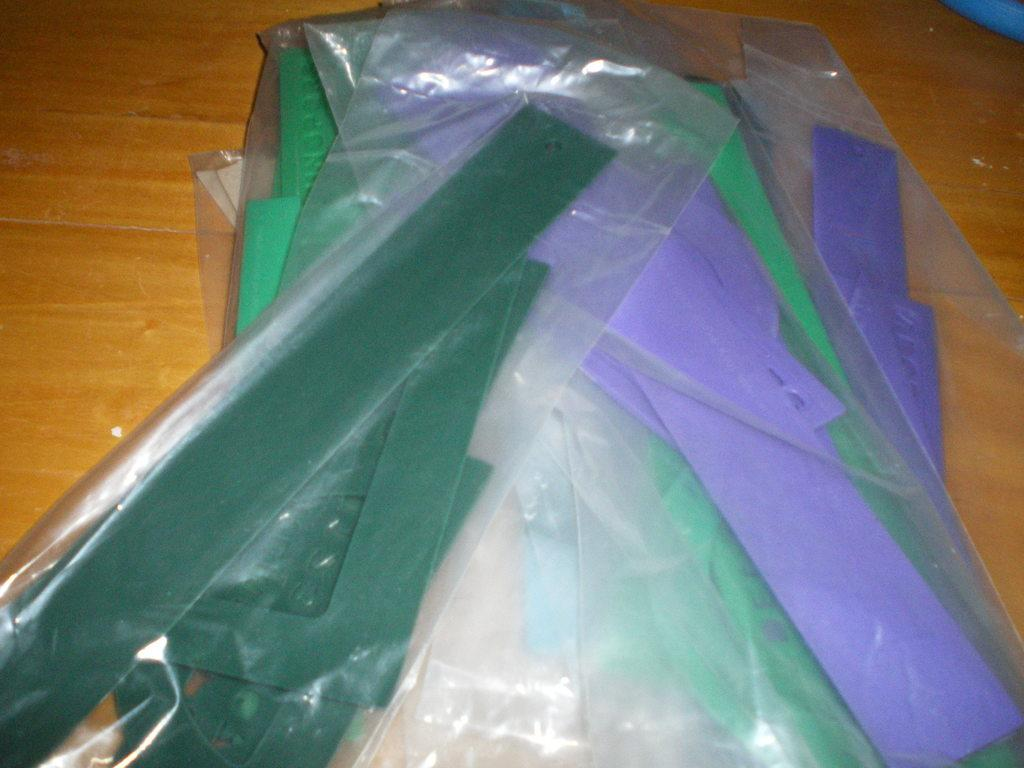What type of objects are in the image? There are plastic objects in the shape of scales in the image. Are the objects visible or covered? The plastic objects are covered. Where are the covered objects located? The covered objects are on a table. What type of beast can be seen interacting with the covered objects in the image? There is no beast present in the image; it only features covered plastic objects in the shape of scales on a table. 